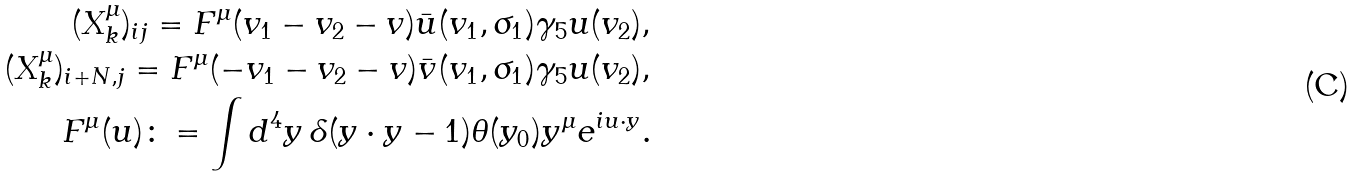<formula> <loc_0><loc_0><loc_500><loc_500>( X ^ { \mu } _ { k } ) _ { i j } = F ^ { \mu } ( v _ { 1 } - v _ { 2 } - v ) \bar { u } ( v _ { 1 } , \sigma _ { 1 } ) \gamma _ { 5 } u ( v _ { 2 } ) , \\ ( X ^ { \mu } _ { k } ) _ { i + N , j } = F ^ { \mu } ( - v _ { 1 } - v _ { 2 } - v ) \bar { v } ( v _ { 1 } , \sigma _ { 1 } ) \gamma _ { 5 } u ( v _ { 2 } ) , \\ F ^ { \mu } ( u ) \colon = \int d ^ { 4 } y \, \delta ( y \cdot y - 1 ) \theta ( y _ { 0 } ) y ^ { \mu } e ^ { i u \cdot y } .</formula> 